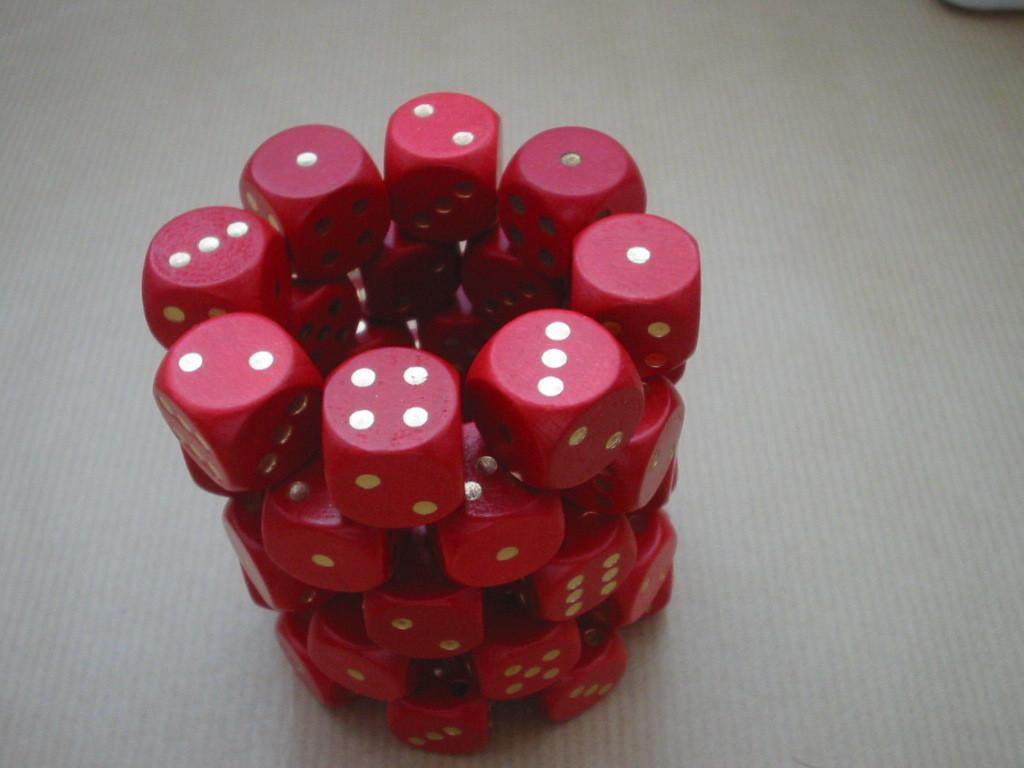Could you give a brief overview of what you see in this image? In this picture there are group of dice arranged in a structure. The dice are in red in color. 